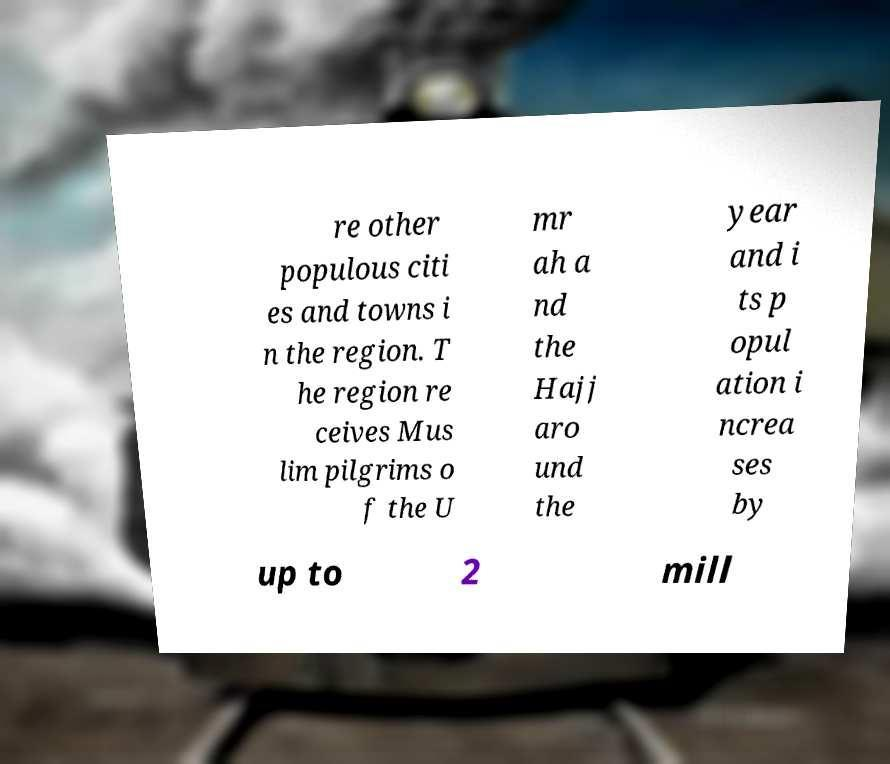What messages or text are displayed in this image? I need them in a readable, typed format. re other populous citi es and towns i n the region. T he region re ceives Mus lim pilgrims o f the U mr ah a nd the Hajj aro und the year and i ts p opul ation i ncrea ses by up to 2 mill 